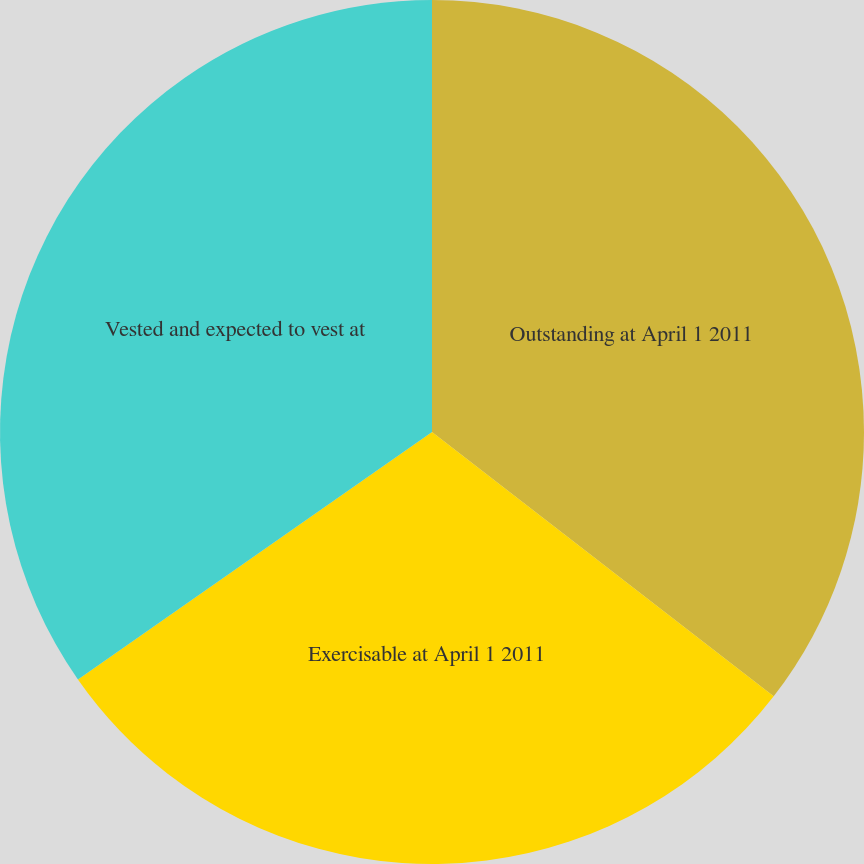Convert chart. <chart><loc_0><loc_0><loc_500><loc_500><pie_chart><fcel>Outstanding at April 1 2011<fcel>Exercisable at April 1 2011<fcel>Vested and expected to vest at<nl><fcel>35.48%<fcel>29.81%<fcel>34.71%<nl></chart> 